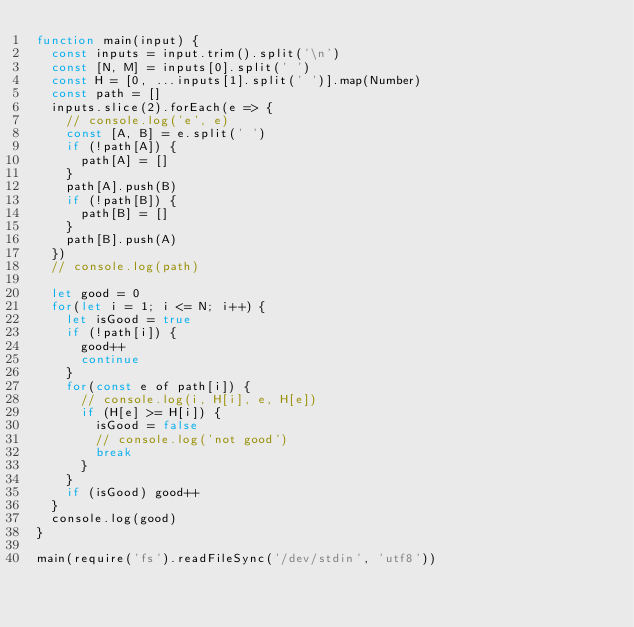Convert code to text. <code><loc_0><loc_0><loc_500><loc_500><_JavaScript_>function main(input) {
  const inputs = input.trim().split('\n')
  const [N, M] = inputs[0].split(' ')
  const H = [0, ...inputs[1].split(' ')].map(Number)
  const path = []
  inputs.slice(2).forEach(e => {
    // console.log('e', e)
    const [A, B] = e.split(' ')
    if (!path[A]) {
      path[A] = []
    }
    path[A].push(B)
    if (!path[B]) {
      path[B] = []
    }
    path[B].push(A)
  })
  // console.log(path)

  let good = 0
  for(let i = 1; i <= N; i++) {
    let isGood = true
    if (!path[i]) {
      good++
      continue
    }
    for(const e of path[i]) {
      // console.log(i, H[i], e, H[e])
      if (H[e] >= H[i]) {
        isGood = false
        // console.log('not good')
        break
      }
    }
    if (isGood) good++
  }
  console.log(good)
}

main(require('fs').readFileSync('/dev/stdin', 'utf8'))</code> 